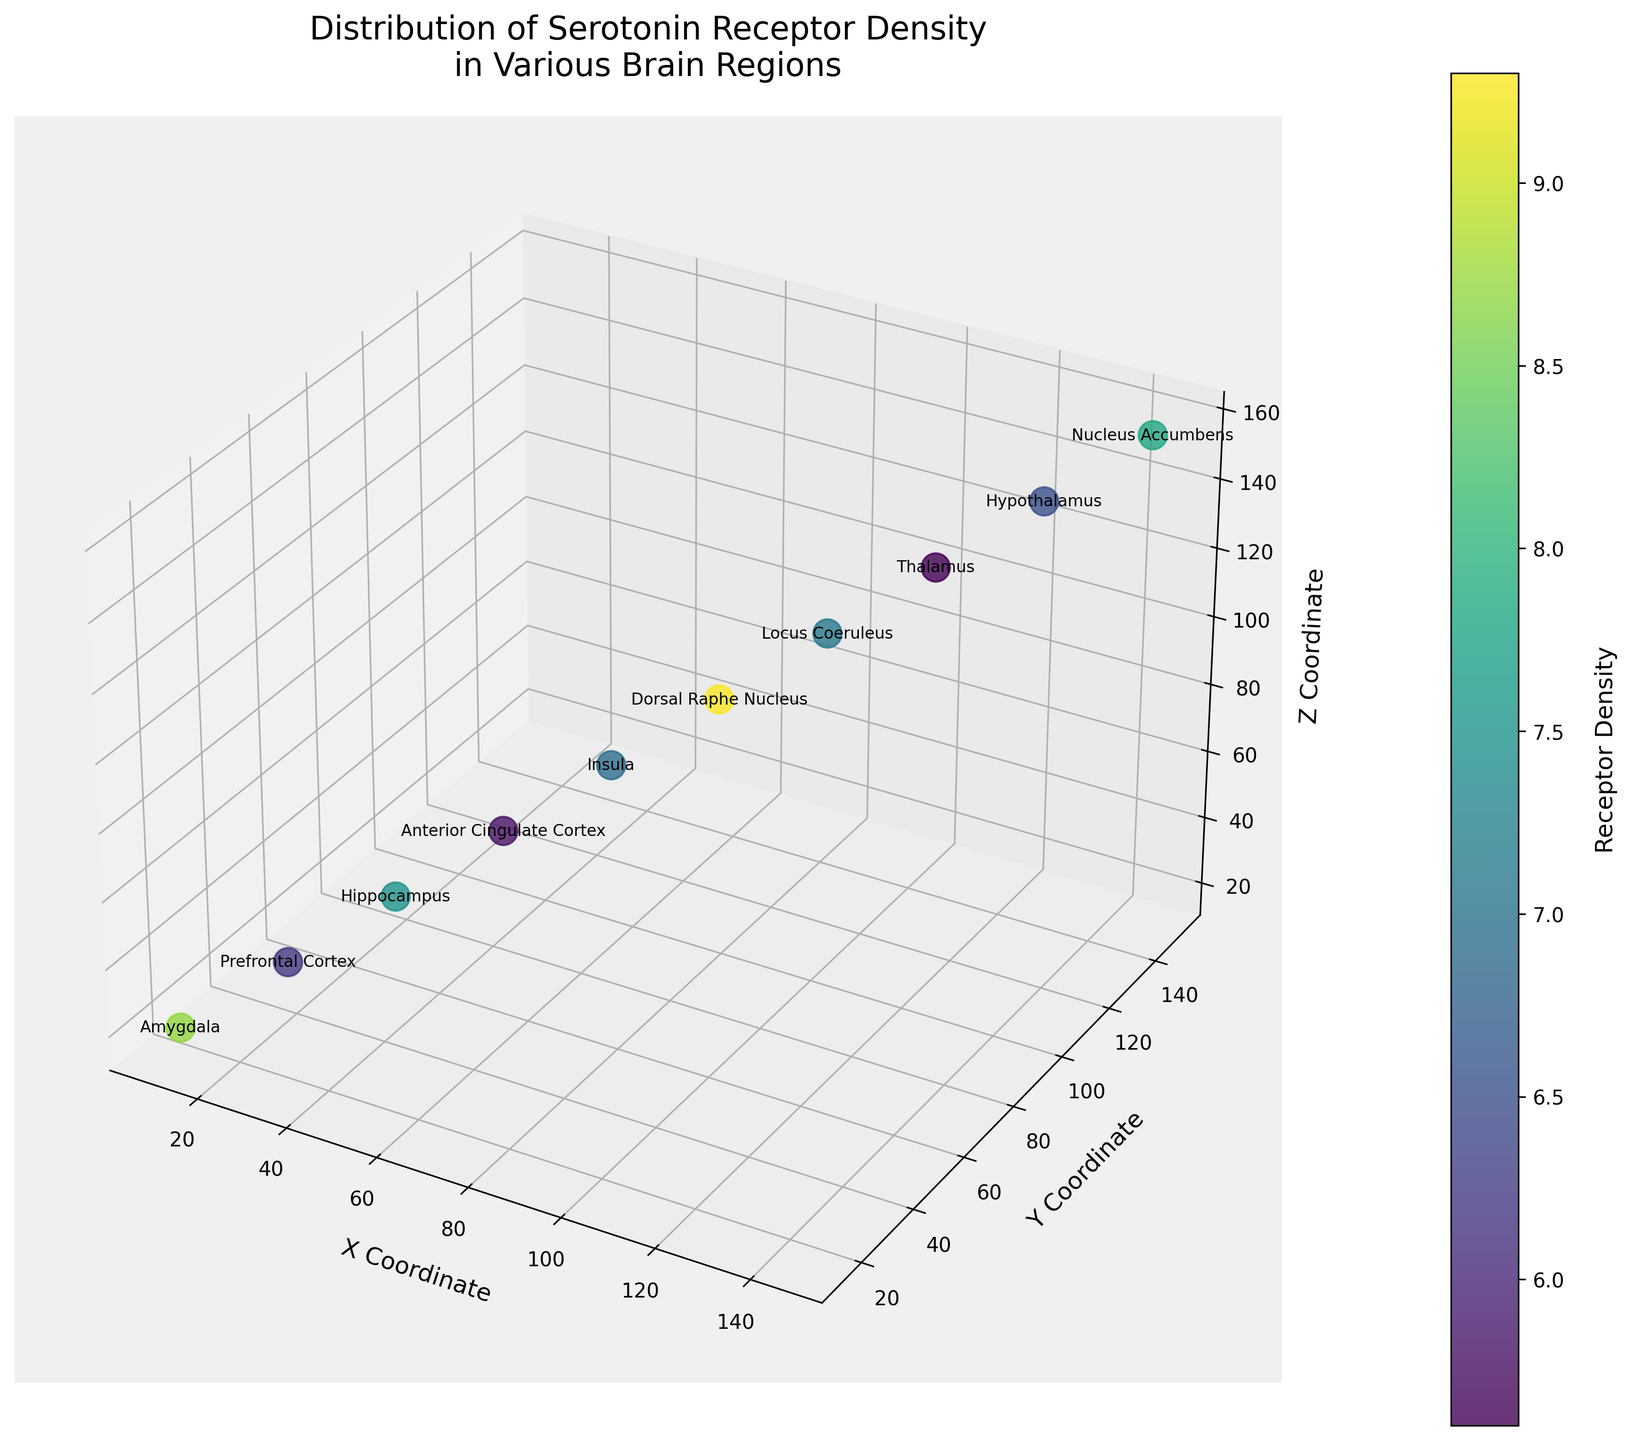What's the title of the plotted figure? The title is located at the top of the figure and describes the content. It reads: 'Distribution of Serotonin Receptor Density in Various Brain Regions'.
Answer: Distribution of Serotonin Receptor Density in Various Brain Regions How many unique brain regions are represented in the plot? Observing the text labels or the legend of different points, we can count the number of unique brain regions mentioned. There are ten different labels, one for each data point, indicating ten unique brain regions.
Answer: 10 Which brain region exhibits the highest serotonin receptor density? By looking into the color mapping (where darker colors indicate higher densities) and the annotations, we identify that the Dorsal Raphe Nucleus (90, 95, 9.3) has the highest density value of 9.3.
Answer: Dorsal Raphe Nucleus What is the receptor density at the Hypothalamus? The corresponding text label or the color mapping overlays the receptor density value directly above the Hypothalamus coordinates (130, 135, 140), showing that it has a density of 6.5.
Answer: 6.5 Compare the serotonin receptor density between the Amygdala and the Prefrontal Cortex. Which is higher? Identify the coordinates and labels for the Amygdala (10, 15, 20) and Prefrontal Cortex (25, 30, 35). Amygdala has a density of 8.7, while Prefrontal Cortex has 6.2. Thus, the density is higher in the Amygdala.
Answer: Amygdala What is the average serotonin receptor density recorded in the plot? Adding all the receptor densities: 8.7 (Amygdala) + 6.2 (Prefrontal Cortex) + 7.5 (Hippocampus) + 5.8 (Anterior Cingulate Cortex) + 6.9 (Insula) + 9.3 (Dorsal Raphe Nucleus) + 7.1 (Locus Coeruleus) + 5.6 (Thalamus) + 6.5 (Hypothalamus) + 7.8 (Nucleus Accumbens) = 71.4. Dividing by number of regions (10) to get the average: 71.4 / 10 = 7.14.
Answer: 7.14 Which brain region has the lowest recorded serotonin receptor density, and what is its value? Locate the point with the lightest shade (lowest density) which is labeled as Thalamus at coordinates (115, 120, 125) showing a receptor density of 5.6.
Answer: Thalamus, 5.6 Is there more variability in the serotonin receptor density between the Dorsal Raphe Nucleus and Nucleus Accumbens compared to the Anterior Cingulate Cortex and Thalamus? Calculate the absolute differences: Dorsal Raphe Nucleus (9.3) - Nucleus Accumbens (7.8) = 1.5, Anterior Cingulate Cortex (5.8) - Thalamus (5.6) = 0.2. The variability between Dorsal Raphe Nucleus and Nucleus Accumbens is greater.
Answer: Yes Imagine you group all brain regions with serotonin receptor densities greater than 7. What's the total receptor density of these regions? Identify such brain regions (Amygdala 8.7, Hippocampus 7.5, Dorsal Raphe Nucleus 9.3, Nucleus Accumbens 7.8): Sum the densities: 8.7 + 7.5 + 9.3 + 7.8 = 33.3.
Answer: 33.3 